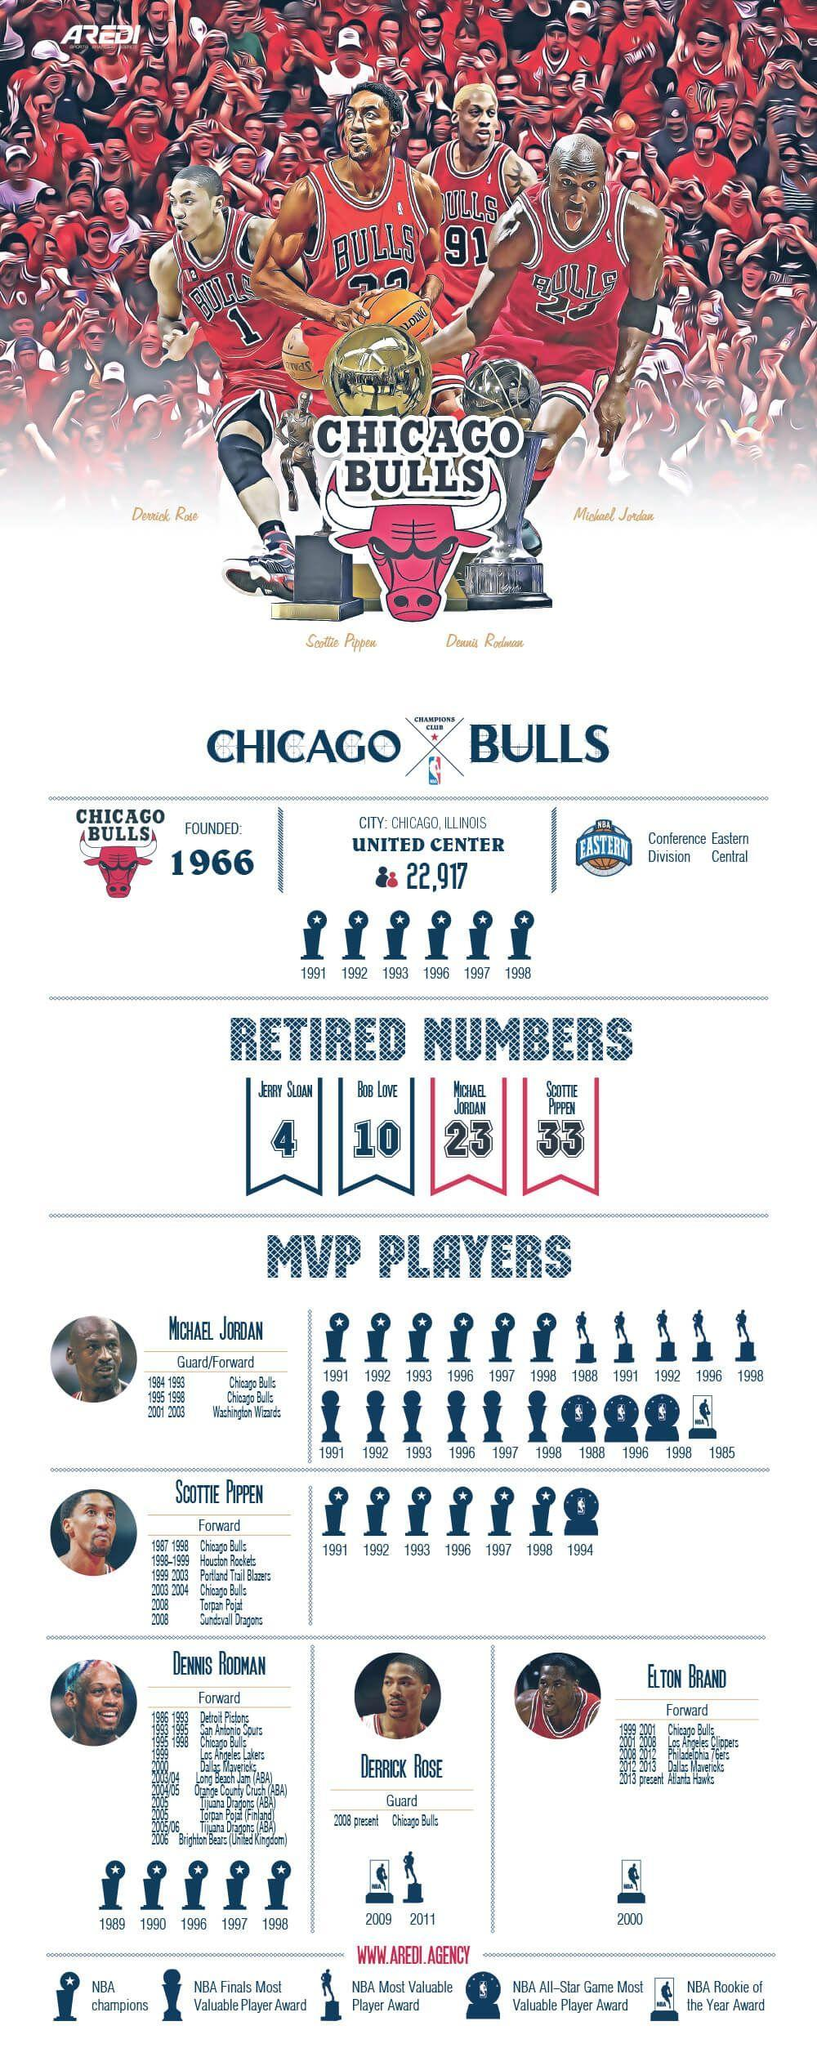Who plays only at guard position
Answer the question with a short phrase. Derick ROse How many teams did Scottie pippen play for 5 Whose T shirt has 1 printed on it Derick ROse Which position does Dennis Rodman play Forward Who play only for forward position Scottie Pippen, Elton Brand, Dennis Rodman how many retired numbers 4 